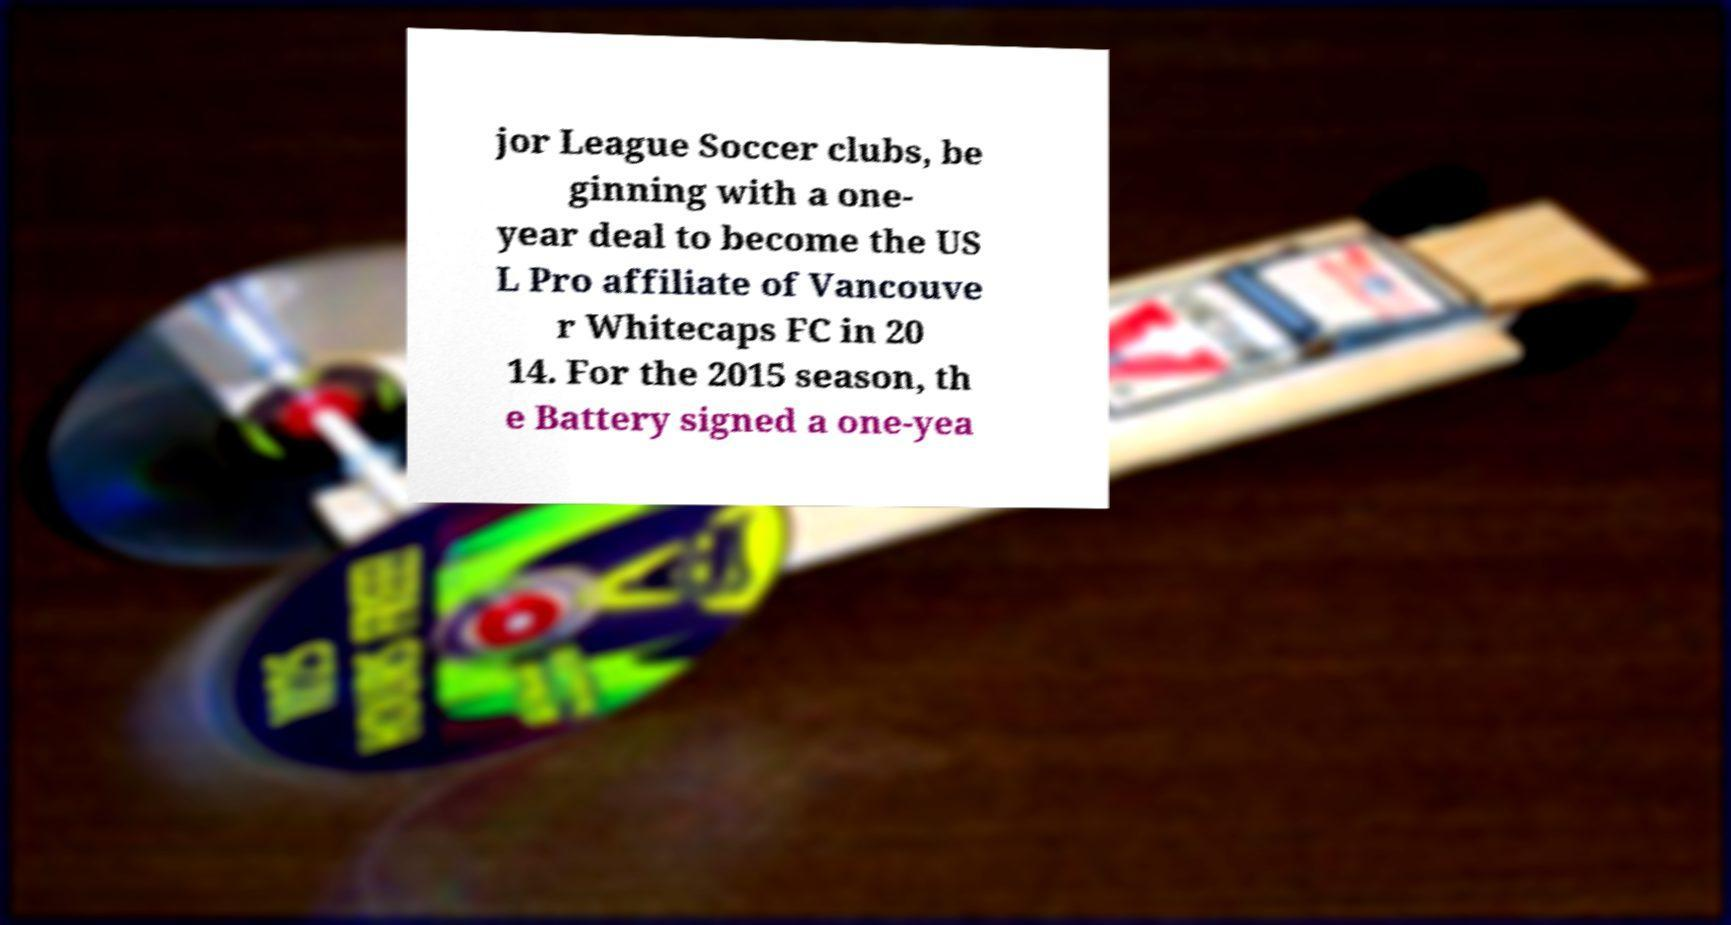Could you extract and type out the text from this image? jor League Soccer clubs, be ginning with a one- year deal to become the US L Pro affiliate of Vancouve r Whitecaps FC in 20 14. For the 2015 season, th e Battery signed a one-yea 